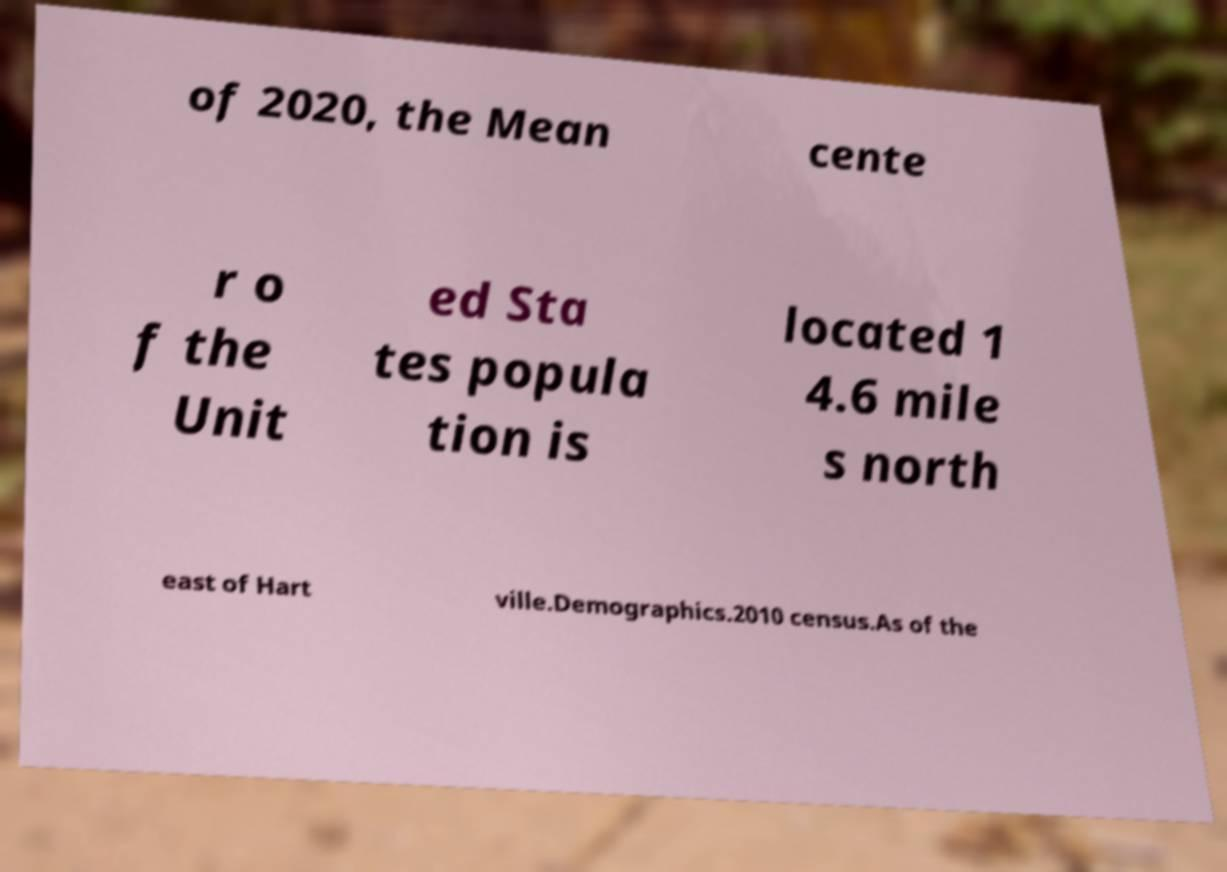Can you read and provide the text displayed in the image?This photo seems to have some interesting text. Can you extract and type it out for me? of 2020, the Mean cente r o f the Unit ed Sta tes popula tion is located 1 4.6 mile s north east of Hart ville.Demographics.2010 census.As of the 